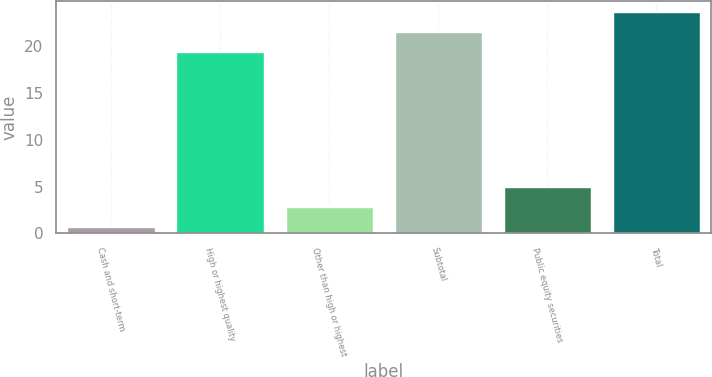<chart> <loc_0><loc_0><loc_500><loc_500><bar_chart><fcel>Cash and short-term<fcel>High or highest quality<fcel>Other than high or highest<fcel>Subtotal<fcel>Public equity securities<fcel>Total<nl><fcel>0.7<fcel>19.4<fcel>2.81<fcel>21.51<fcel>4.92<fcel>23.62<nl></chart> 